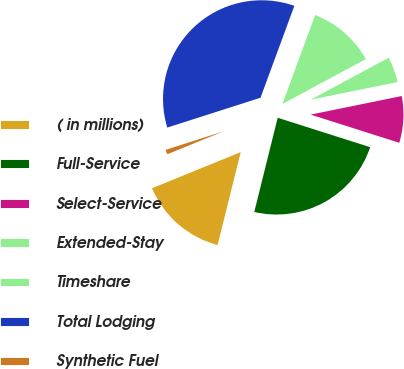<chart> <loc_0><loc_0><loc_500><loc_500><pie_chart><fcel>( in millions)<fcel>Full-Service<fcel>Select-Service<fcel>Extended-Stay<fcel>Timeshare<fcel>Total Lodging<fcel>Synthetic Fuel<nl><fcel>14.96%<fcel>23.98%<fcel>8.1%<fcel>4.66%<fcel>11.53%<fcel>35.55%<fcel>1.23%<nl></chart> 